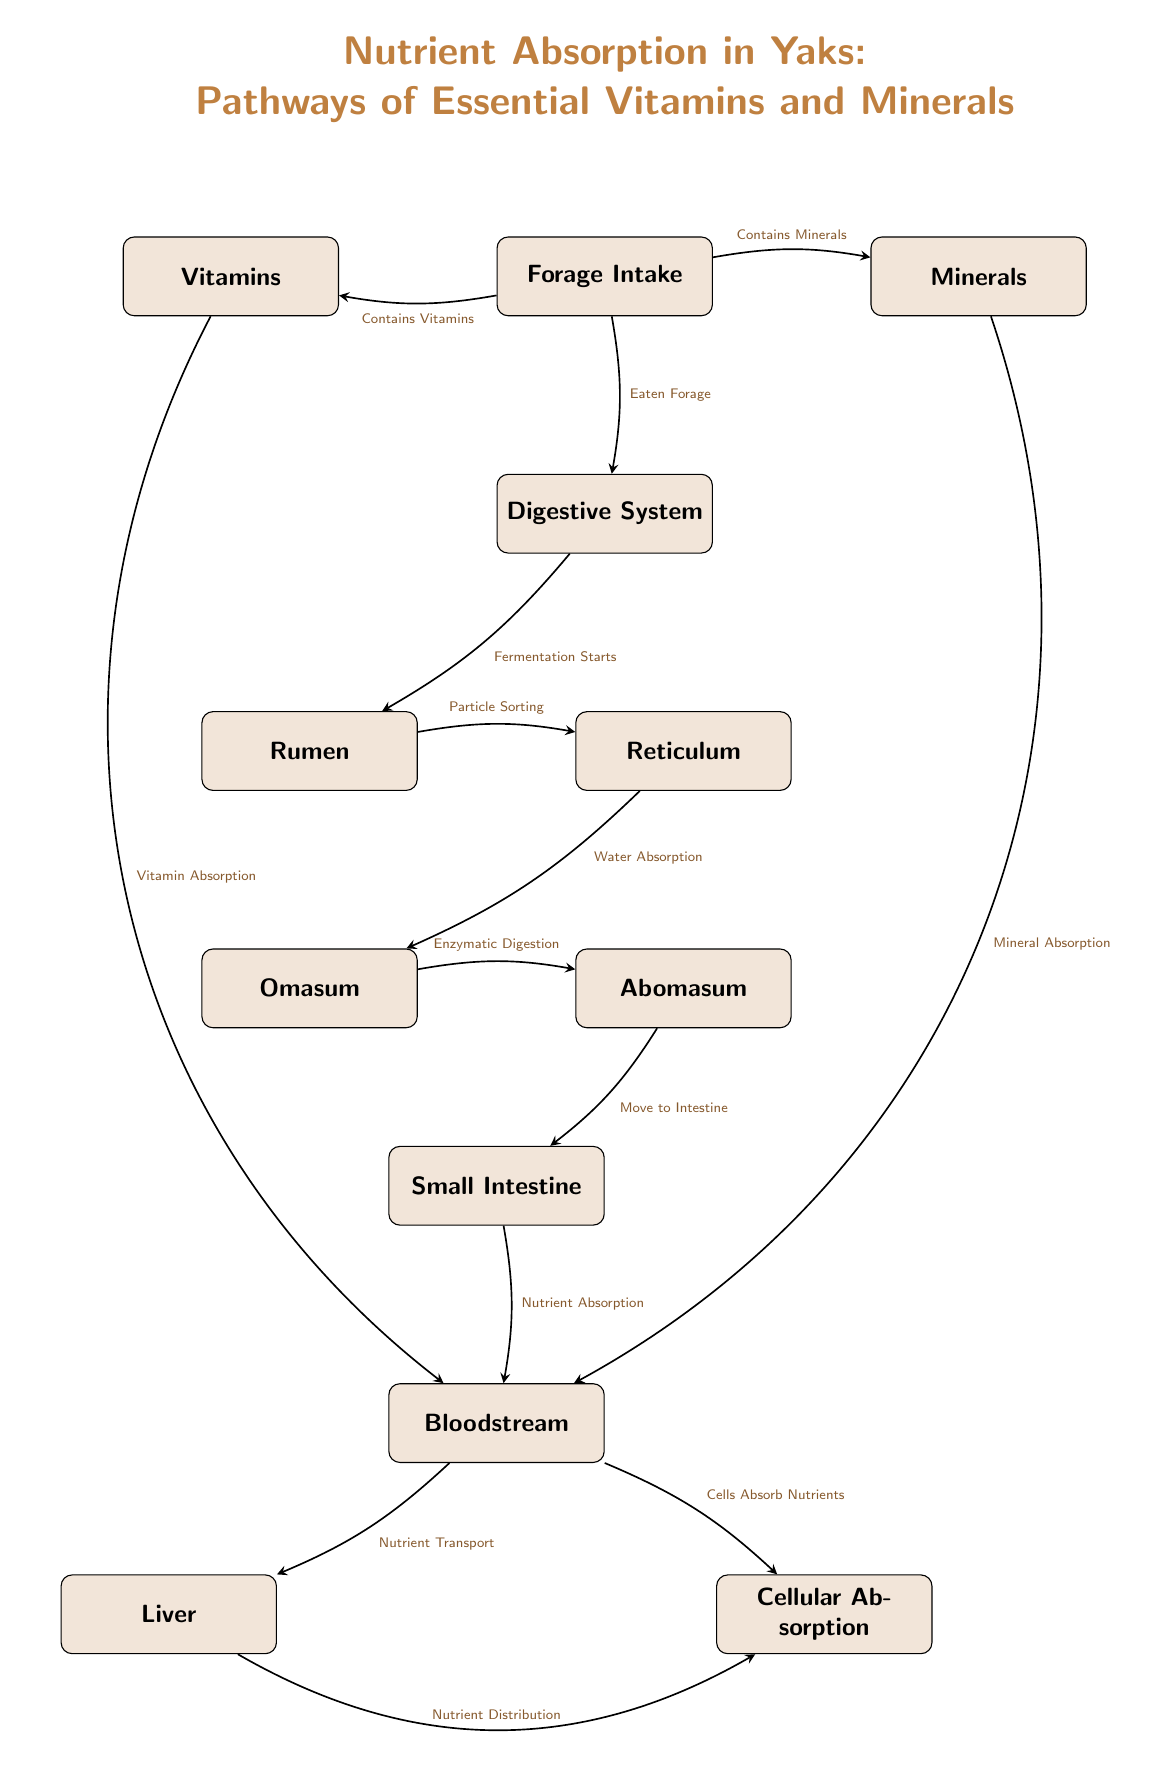What is the first step after forage intake? The diagram indicates that after forage intake, the first step is the "Digestive System" where digestion begins.
Answer: Digestive System How many main parts are involved in the digestive process? The diagram identifies five main parts involved in digestion: Rumen, Reticulum, Omasum, Abomasum, and Small Intestine, making a total of five.
Answer: 5 What process occurs in the reticulum? The diagram specifies that "Particle Sorting" takes place in the Reticulum as a part of the digestion process.
Answer: Particle Sorting What is the final destination of nutrients after they enter the bloodstream? According to the diagram, the nutrients' final destination after entering the bloodstream is "Cellular Absorption", where cells absorb the nutrients.
Answer: Cellular Absorption Which two components are directly linked to forage intake? The diagram shows that forage intake is directly linked to both "Vitamins" and "Minerals", indicating that forage provides these essential nutrients.
Answer: Vitamins and Minerals What process facilitates water absorption in the digestive pathway? The pathway in the diagram indicates that "Water Absorption" occurs in the Reticulum as part of the digestive process.
Answer: Water Absorption Which organ is responsible for nutrient distribution to cells? From the diagram, the "Liver" is depicted as the organ that is responsible for "Nutrient Distribution" to cells after the bloodstream.
Answer: Liver Which type of absorption occurs after nutrients reach the bloodstream? The diagram identifies that after nutrients reach the bloodstream, they undergo "Cells Absorb Nutrients", which is the absorption process at the cellular level.
Answer: Cells Absorb Nutrients How does mineral absorption connect to the process shown in the diagram? The diagram shows that "Mineral Absorption" occurs as an outcome of forage intake, which then proceeds to the bloodstream, indicating its connection to the overall nutrient absorption process.
Answer: Mineral Absorption 